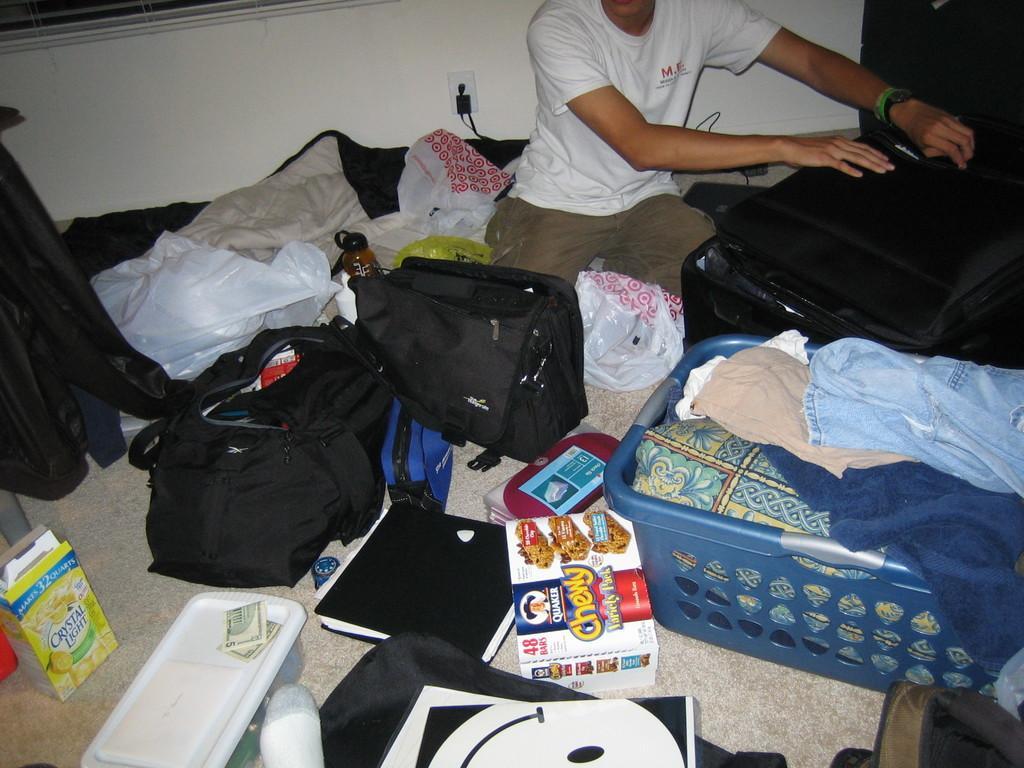Please provide a concise description of this image. In this picture is a person there is a person sitting over here and is holding a suitcase and there are some bags, books, objects placed on the floor. 